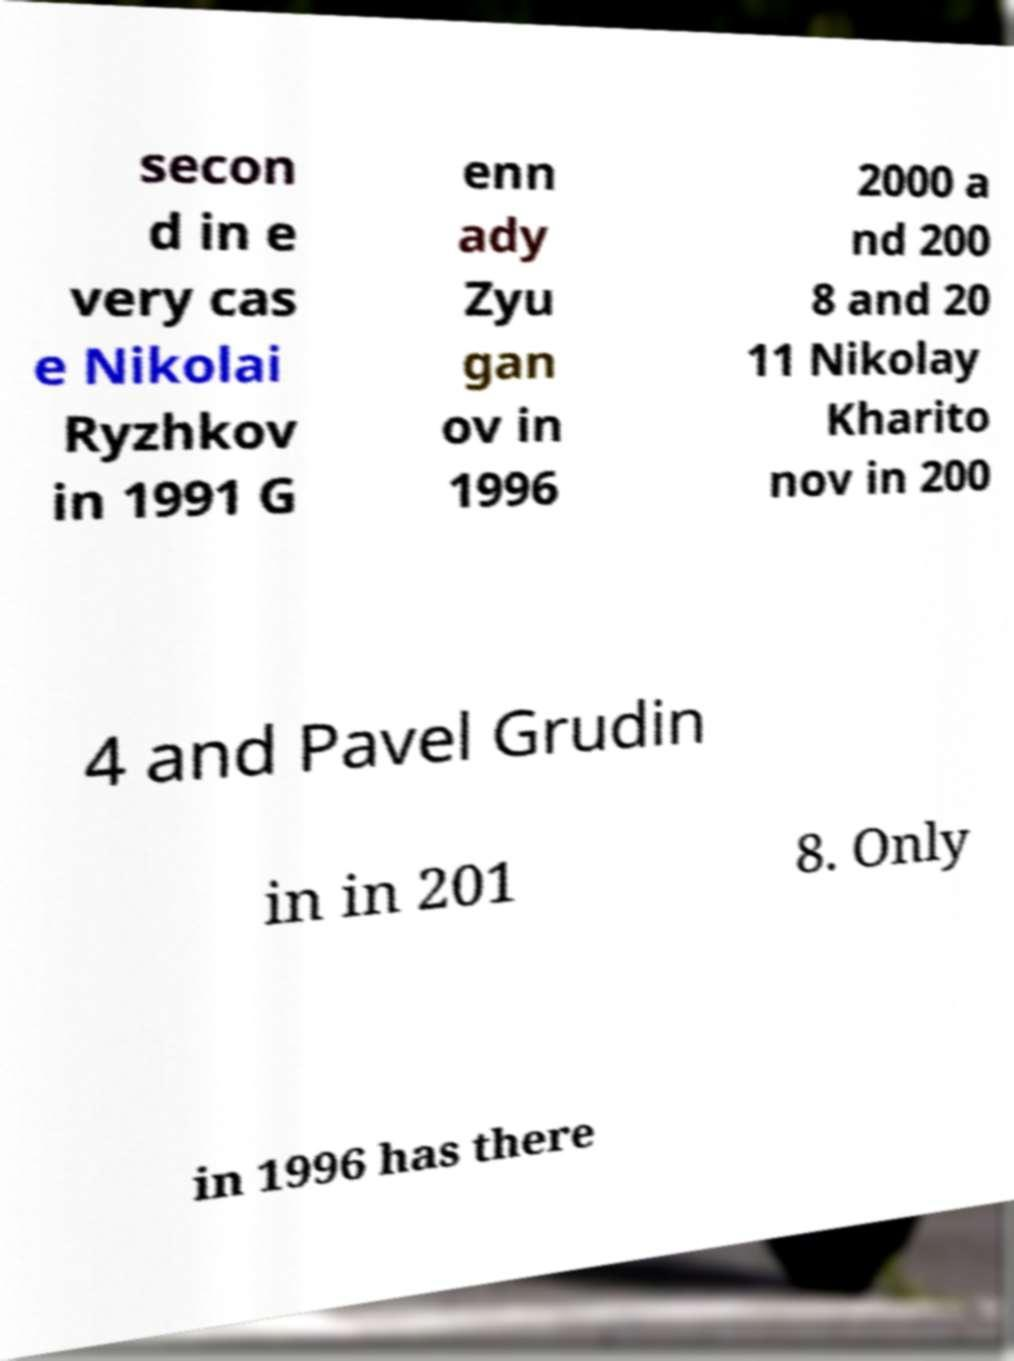Please identify and transcribe the text found in this image. secon d in e very cas e Nikolai Ryzhkov in 1991 G enn ady Zyu gan ov in 1996 2000 a nd 200 8 and 20 11 Nikolay Kharito nov in 200 4 and Pavel Grudin in in 201 8. Only in 1996 has there 